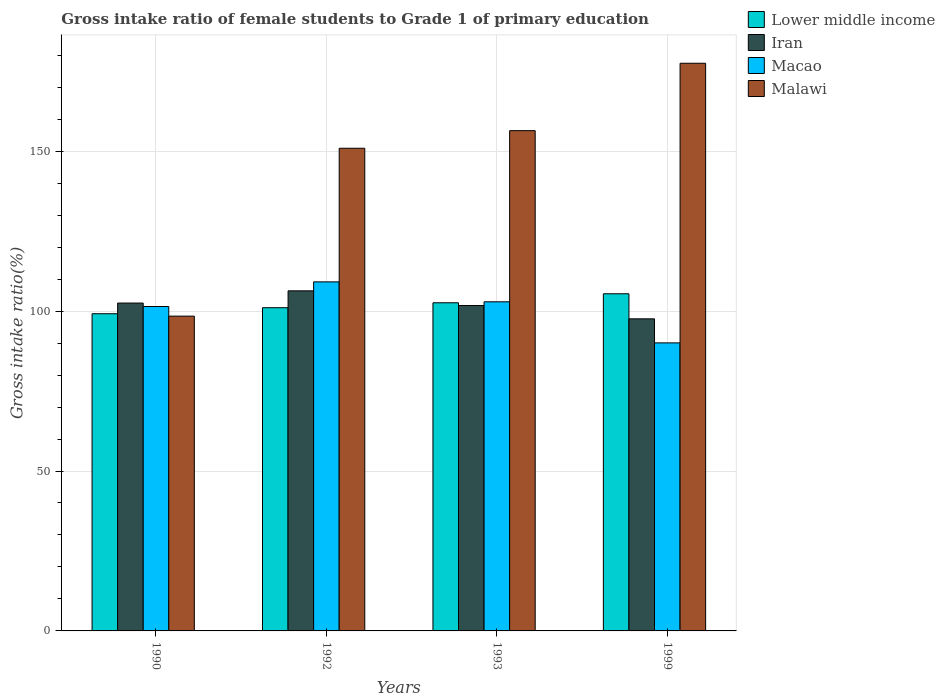How many groups of bars are there?
Provide a succinct answer. 4. What is the label of the 1st group of bars from the left?
Provide a succinct answer. 1990. In how many cases, is the number of bars for a given year not equal to the number of legend labels?
Your response must be concise. 0. What is the gross intake ratio in Iran in 1990?
Make the answer very short. 102.52. Across all years, what is the maximum gross intake ratio in Macao?
Ensure brevity in your answer.  109.15. Across all years, what is the minimum gross intake ratio in Malawi?
Your answer should be very brief. 98.43. In which year was the gross intake ratio in Lower middle income maximum?
Provide a succinct answer. 1999. What is the total gross intake ratio in Iran in the graph?
Make the answer very short. 408.2. What is the difference between the gross intake ratio in Iran in 1992 and that in 1993?
Make the answer very short. 4.59. What is the difference between the gross intake ratio in Macao in 1999 and the gross intake ratio in Malawi in 1990?
Ensure brevity in your answer.  -8.37. What is the average gross intake ratio in Iran per year?
Give a very brief answer. 102.05. In the year 1993, what is the difference between the gross intake ratio in Malawi and gross intake ratio in Macao?
Keep it short and to the point. 53.51. What is the ratio of the gross intake ratio in Macao in 1990 to that in 1992?
Keep it short and to the point. 0.93. What is the difference between the highest and the second highest gross intake ratio in Malawi?
Your answer should be very brief. 21.08. What is the difference between the highest and the lowest gross intake ratio in Macao?
Offer a very short reply. 19.08. In how many years, is the gross intake ratio in Lower middle income greater than the average gross intake ratio in Lower middle income taken over all years?
Your response must be concise. 2. Is it the case that in every year, the sum of the gross intake ratio in Lower middle income and gross intake ratio in Malawi is greater than the sum of gross intake ratio in Macao and gross intake ratio in Iran?
Your answer should be very brief. Yes. What does the 1st bar from the left in 1993 represents?
Your answer should be very brief. Lower middle income. What does the 2nd bar from the right in 1990 represents?
Your answer should be very brief. Macao. Is it the case that in every year, the sum of the gross intake ratio in Lower middle income and gross intake ratio in Malawi is greater than the gross intake ratio in Macao?
Give a very brief answer. Yes. How many years are there in the graph?
Keep it short and to the point. 4. What is the title of the graph?
Your answer should be very brief. Gross intake ratio of female students to Grade 1 of primary education. What is the label or title of the X-axis?
Provide a succinct answer. Years. What is the label or title of the Y-axis?
Keep it short and to the point. Gross intake ratio(%). What is the Gross intake ratio(%) of Lower middle income in 1990?
Give a very brief answer. 99.19. What is the Gross intake ratio(%) of Iran in 1990?
Keep it short and to the point. 102.52. What is the Gross intake ratio(%) of Macao in 1990?
Give a very brief answer. 101.44. What is the Gross intake ratio(%) in Malawi in 1990?
Provide a short and direct response. 98.43. What is the Gross intake ratio(%) in Lower middle income in 1992?
Your answer should be very brief. 101.07. What is the Gross intake ratio(%) of Iran in 1992?
Ensure brevity in your answer.  106.34. What is the Gross intake ratio(%) in Macao in 1992?
Offer a terse response. 109.15. What is the Gross intake ratio(%) in Malawi in 1992?
Give a very brief answer. 150.93. What is the Gross intake ratio(%) in Lower middle income in 1993?
Give a very brief answer. 102.61. What is the Gross intake ratio(%) of Iran in 1993?
Make the answer very short. 101.75. What is the Gross intake ratio(%) in Macao in 1993?
Give a very brief answer. 102.91. What is the Gross intake ratio(%) in Malawi in 1993?
Give a very brief answer. 156.42. What is the Gross intake ratio(%) in Lower middle income in 1999?
Make the answer very short. 105.42. What is the Gross intake ratio(%) of Iran in 1999?
Your answer should be very brief. 97.59. What is the Gross intake ratio(%) in Macao in 1999?
Make the answer very short. 90.07. What is the Gross intake ratio(%) of Malawi in 1999?
Offer a very short reply. 177.5. Across all years, what is the maximum Gross intake ratio(%) of Lower middle income?
Keep it short and to the point. 105.42. Across all years, what is the maximum Gross intake ratio(%) in Iran?
Ensure brevity in your answer.  106.34. Across all years, what is the maximum Gross intake ratio(%) in Macao?
Keep it short and to the point. 109.15. Across all years, what is the maximum Gross intake ratio(%) of Malawi?
Your answer should be compact. 177.5. Across all years, what is the minimum Gross intake ratio(%) in Lower middle income?
Provide a short and direct response. 99.19. Across all years, what is the minimum Gross intake ratio(%) in Iran?
Your answer should be compact. 97.59. Across all years, what is the minimum Gross intake ratio(%) of Macao?
Offer a terse response. 90.07. Across all years, what is the minimum Gross intake ratio(%) in Malawi?
Your answer should be compact. 98.43. What is the total Gross intake ratio(%) in Lower middle income in the graph?
Your answer should be compact. 408.28. What is the total Gross intake ratio(%) in Iran in the graph?
Ensure brevity in your answer.  408.2. What is the total Gross intake ratio(%) in Macao in the graph?
Offer a very short reply. 403.56. What is the total Gross intake ratio(%) of Malawi in the graph?
Give a very brief answer. 583.29. What is the difference between the Gross intake ratio(%) in Lower middle income in 1990 and that in 1992?
Offer a very short reply. -1.88. What is the difference between the Gross intake ratio(%) in Iran in 1990 and that in 1992?
Provide a short and direct response. -3.82. What is the difference between the Gross intake ratio(%) of Macao in 1990 and that in 1992?
Offer a terse response. -7.71. What is the difference between the Gross intake ratio(%) in Malawi in 1990 and that in 1992?
Make the answer very short. -52.5. What is the difference between the Gross intake ratio(%) in Lower middle income in 1990 and that in 1993?
Provide a succinct answer. -3.42. What is the difference between the Gross intake ratio(%) of Iran in 1990 and that in 1993?
Make the answer very short. 0.77. What is the difference between the Gross intake ratio(%) in Macao in 1990 and that in 1993?
Offer a very short reply. -1.47. What is the difference between the Gross intake ratio(%) of Malawi in 1990 and that in 1993?
Your response must be concise. -57.99. What is the difference between the Gross intake ratio(%) in Lower middle income in 1990 and that in 1999?
Keep it short and to the point. -6.24. What is the difference between the Gross intake ratio(%) of Iran in 1990 and that in 1999?
Ensure brevity in your answer.  4.93. What is the difference between the Gross intake ratio(%) of Macao in 1990 and that in 1999?
Offer a very short reply. 11.37. What is the difference between the Gross intake ratio(%) in Malawi in 1990 and that in 1999?
Keep it short and to the point. -79.07. What is the difference between the Gross intake ratio(%) in Lower middle income in 1992 and that in 1993?
Your answer should be very brief. -1.54. What is the difference between the Gross intake ratio(%) in Iran in 1992 and that in 1993?
Offer a terse response. 4.59. What is the difference between the Gross intake ratio(%) of Macao in 1992 and that in 1993?
Offer a very short reply. 6.23. What is the difference between the Gross intake ratio(%) of Malawi in 1992 and that in 1993?
Offer a very short reply. -5.5. What is the difference between the Gross intake ratio(%) in Lower middle income in 1992 and that in 1999?
Ensure brevity in your answer.  -4.36. What is the difference between the Gross intake ratio(%) in Iran in 1992 and that in 1999?
Give a very brief answer. 8.75. What is the difference between the Gross intake ratio(%) of Macao in 1992 and that in 1999?
Your answer should be compact. 19.08. What is the difference between the Gross intake ratio(%) in Malawi in 1992 and that in 1999?
Offer a very short reply. -26.58. What is the difference between the Gross intake ratio(%) in Lower middle income in 1993 and that in 1999?
Keep it short and to the point. -2.81. What is the difference between the Gross intake ratio(%) of Iran in 1993 and that in 1999?
Provide a succinct answer. 4.16. What is the difference between the Gross intake ratio(%) of Macao in 1993 and that in 1999?
Your answer should be compact. 12.85. What is the difference between the Gross intake ratio(%) in Malawi in 1993 and that in 1999?
Your answer should be compact. -21.08. What is the difference between the Gross intake ratio(%) of Lower middle income in 1990 and the Gross intake ratio(%) of Iran in 1992?
Offer a very short reply. -7.16. What is the difference between the Gross intake ratio(%) in Lower middle income in 1990 and the Gross intake ratio(%) in Macao in 1992?
Make the answer very short. -9.96. What is the difference between the Gross intake ratio(%) in Lower middle income in 1990 and the Gross intake ratio(%) in Malawi in 1992?
Provide a short and direct response. -51.74. What is the difference between the Gross intake ratio(%) of Iran in 1990 and the Gross intake ratio(%) of Macao in 1992?
Your answer should be compact. -6.63. What is the difference between the Gross intake ratio(%) of Iran in 1990 and the Gross intake ratio(%) of Malawi in 1992?
Provide a short and direct response. -48.41. What is the difference between the Gross intake ratio(%) of Macao in 1990 and the Gross intake ratio(%) of Malawi in 1992?
Make the answer very short. -49.49. What is the difference between the Gross intake ratio(%) in Lower middle income in 1990 and the Gross intake ratio(%) in Iran in 1993?
Provide a short and direct response. -2.56. What is the difference between the Gross intake ratio(%) in Lower middle income in 1990 and the Gross intake ratio(%) in Macao in 1993?
Your answer should be very brief. -3.72. What is the difference between the Gross intake ratio(%) in Lower middle income in 1990 and the Gross intake ratio(%) in Malawi in 1993?
Ensure brevity in your answer.  -57.24. What is the difference between the Gross intake ratio(%) in Iran in 1990 and the Gross intake ratio(%) in Macao in 1993?
Give a very brief answer. -0.39. What is the difference between the Gross intake ratio(%) of Iran in 1990 and the Gross intake ratio(%) of Malawi in 1993?
Offer a terse response. -53.9. What is the difference between the Gross intake ratio(%) of Macao in 1990 and the Gross intake ratio(%) of Malawi in 1993?
Provide a short and direct response. -54.98. What is the difference between the Gross intake ratio(%) in Lower middle income in 1990 and the Gross intake ratio(%) in Iran in 1999?
Your answer should be very brief. 1.6. What is the difference between the Gross intake ratio(%) in Lower middle income in 1990 and the Gross intake ratio(%) in Macao in 1999?
Offer a very short reply. 9.12. What is the difference between the Gross intake ratio(%) in Lower middle income in 1990 and the Gross intake ratio(%) in Malawi in 1999?
Your answer should be very brief. -78.32. What is the difference between the Gross intake ratio(%) in Iran in 1990 and the Gross intake ratio(%) in Macao in 1999?
Offer a very short reply. 12.45. What is the difference between the Gross intake ratio(%) of Iran in 1990 and the Gross intake ratio(%) of Malawi in 1999?
Make the answer very short. -74.98. What is the difference between the Gross intake ratio(%) of Macao in 1990 and the Gross intake ratio(%) of Malawi in 1999?
Make the answer very short. -76.06. What is the difference between the Gross intake ratio(%) in Lower middle income in 1992 and the Gross intake ratio(%) in Iran in 1993?
Provide a short and direct response. -0.68. What is the difference between the Gross intake ratio(%) of Lower middle income in 1992 and the Gross intake ratio(%) of Macao in 1993?
Your answer should be compact. -1.85. What is the difference between the Gross intake ratio(%) in Lower middle income in 1992 and the Gross intake ratio(%) in Malawi in 1993?
Provide a succinct answer. -55.36. What is the difference between the Gross intake ratio(%) of Iran in 1992 and the Gross intake ratio(%) of Macao in 1993?
Offer a very short reply. 3.43. What is the difference between the Gross intake ratio(%) in Iran in 1992 and the Gross intake ratio(%) in Malawi in 1993?
Offer a terse response. -50.08. What is the difference between the Gross intake ratio(%) in Macao in 1992 and the Gross intake ratio(%) in Malawi in 1993?
Provide a short and direct response. -47.28. What is the difference between the Gross intake ratio(%) of Lower middle income in 1992 and the Gross intake ratio(%) of Iran in 1999?
Provide a short and direct response. 3.48. What is the difference between the Gross intake ratio(%) of Lower middle income in 1992 and the Gross intake ratio(%) of Macao in 1999?
Offer a very short reply. 11. What is the difference between the Gross intake ratio(%) in Lower middle income in 1992 and the Gross intake ratio(%) in Malawi in 1999?
Keep it short and to the point. -76.44. What is the difference between the Gross intake ratio(%) in Iran in 1992 and the Gross intake ratio(%) in Macao in 1999?
Offer a very short reply. 16.28. What is the difference between the Gross intake ratio(%) of Iran in 1992 and the Gross intake ratio(%) of Malawi in 1999?
Make the answer very short. -71.16. What is the difference between the Gross intake ratio(%) of Macao in 1992 and the Gross intake ratio(%) of Malawi in 1999?
Make the answer very short. -68.36. What is the difference between the Gross intake ratio(%) of Lower middle income in 1993 and the Gross intake ratio(%) of Iran in 1999?
Keep it short and to the point. 5.02. What is the difference between the Gross intake ratio(%) in Lower middle income in 1993 and the Gross intake ratio(%) in Macao in 1999?
Keep it short and to the point. 12.54. What is the difference between the Gross intake ratio(%) of Lower middle income in 1993 and the Gross intake ratio(%) of Malawi in 1999?
Offer a very short reply. -74.9. What is the difference between the Gross intake ratio(%) of Iran in 1993 and the Gross intake ratio(%) of Macao in 1999?
Your response must be concise. 11.68. What is the difference between the Gross intake ratio(%) of Iran in 1993 and the Gross intake ratio(%) of Malawi in 1999?
Give a very brief answer. -75.76. What is the difference between the Gross intake ratio(%) in Macao in 1993 and the Gross intake ratio(%) in Malawi in 1999?
Provide a short and direct response. -74.59. What is the average Gross intake ratio(%) of Lower middle income per year?
Provide a succinct answer. 102.07. What is the average Gross intake ratio(%) of Iran per year?
Provide a short and direct response. 102.05. What is the average Gross intake ratio(%) in Macao per year?
Your answer should be very brief. 100.89. What is the average Gross intake ratio(%) of Malawi per year?
Your answer should be compact. 145.82. In the year 1990, what is the difference between the Gross intake ratio(%) in Lower middle income and Gross intake ratio(%) in Iran?
Keep it short and to the point. -3.33. In the year 1990, what is the difference between the Gross intake ratio(%) in Lower middle income and Gross intake ratio(%) in Macao?
Make the answer very short. -2.25. In the year 1990, what is the difference between the Gross intake ratio(%) in Lower middle income and Gross intake ratio(%) in Malawi?
Provide a short and direct response. 0.75. In the year 1990, what is the difference between the Gross intake ratio(%) of Iran and Gross intake ratio(%) of Macao?
Provide a short and direct response. 1.08. In the year 1990, what is the difference between the Gross intake ratio(%) of Iran and Gross intake ratio(%) of Malawi?
Give a very brief answer. 4.09. In the year 1990, what is the difference between the Gross intake ratio(%) of Macao and Gross intake ratio(%) of Malawi?
Offer a very short reply. 3.01. In the year 1992, what is the difference between the Gross intake ratio(%) in Lower middle income and Gross intake ratio(%) in Iran?
Your response must be concise. -5.28. In the year 1992, what is the difference between the Gross intake ratio(%) in Lower middle income and Gross intake ratio(%) in Macao?
Offer a very short reply. -8.08. In the year 1992, what is the difference between the Gross intake ratio(%) of Lower middle income and Gross intake ratio(%) of Malawi?
Your answer should be compact. -49.86. In the year 1992, what is the difference between the Gross intake ratio(%) of Iran and Gross intake ratio(%) of Macao?
Offer a terse response. -2.8. In the year 1992, what is the difference between the Gross intake ratio(%) of Iran and Gross intake ratio(%) of Malawi?
Offer a terse response. -44.58. In the year 1992, what is the difference between the Gross intake ratio(%) of Macao and Gross intake ratio(%) of Malawi?
Offer a terse response. -41.78. In the year 1993, what is the difference between the Gross intake ratio(%) of Lower middle income and Gross intake ratio(%) of Iran?
Make the answer very short. 0.86. In the year 1993, what is the difference between the Gross intake ratio(%) of Lower middle income and Gross intake ratio(%) of Macao?
Your answer should be compact. -0.3. In the year 1993, what is the difference between the Gross intake ratio(%) of Lower middle income and Gross intake ratio(%) of Malawi?
Your response must be concise. -53.82. In the year 1993, what is the difference between the Gross intake ratio(%) of Iran and Gross intake ratio(%) of Macao?
Offer a terse response. -1.16. In the year 1993, what is the difference between the Gross intake ratio(%) in Iran and Gross intake ratio(%) in Malawi?
Ensure brevity in your answer.  -54.68. In the year 1993, what is the difference between the Gross intake ratio(%) of Macao and Gross intake ratio(%) of Malawi?
Offer a terse response. -53.51. In the year 1999, what is the difference between the Gross intake ratio(%) in Lower middle income and Gross intake ratio(%) in Iran?
Make the answer very short. 7.83. In the year 1999, what is the difference between the Gross intake ratio(%) of Lower middle income and Gross intake ratio(%) of Macao?
Provide a succinct answer. 15.36. In the year 1999, what is the difference between the Gross intake ratio(%) in Lower middle income and Gross intake ratio(%) in Malawi?
Your answer should be compact. -72.08. In the year 1999, what is the difference between the Gross intake ratio(%) in Iran and Gross intake ratio(%) in Macao?
Your answer should be compact. 7.52. In the year 1999, what is the difference between the Gross intake ratio(%) in Iran and Gross intake ratio(%) in Malawi?
Provide a succinct answer. -79.92. In the year 1999, what is the difference between the Gross intake ratio(%) in Macao and Gross intake ratio(%) in Malawi?
Keep it short and to the point. -87.44. What is the ratio of the Gross intake ratio(%) in Lower middle income in 1990 to that in 1992?
Offer a very short reply. 0.98. What is the ratio of the Gross intake ratio(%) in Iran in 1990 to that in 1992?
Provide a short and direct response. 0.96. What is the ratio of the Gross intake ratio(%) in Macao in 1990 to that in 1992?
Your response must be concise. 0.93. What is the ratio of the Gross intake ratio(%) of Malawi in 1990 to that in 1992?
Offer a very short reply. 0.65. What is the ratio of the Gross intake ratio(%) of Lower middle income in 1990 to that in 1993?
Offer a very short reply. 0.97. What is the ratio of the Gross intake ratio(%) of Iran in 1990 to that in 1993?
Your response must be concise. 1.01. What is the ratio of the Gross intake ratio(%) of Macao in 1990 to that in 1993?
Your answer should be compact. 0.99. What is the ratio of the Gross intake ratio(%) in Malawi in 1990 to that in 1993?
Provide a short and direct response. 0.63. What is the ratio of the Gross intake ratio(%) in Lower middle income in 1990 to that in 1999?
Your answer should be very brief. 0.94. What is the ratio of the Gross intake ratio(%) in Iran in 1990 to that in 1999?
Keep it short and to the point. 1.05. What is the ratio of the Gross intake ratio(%) of Macao in 1990 to that in 1999?
Offer a terse response. 1.13. What is the ratio of the Gross intake ratio(%) in Malawi in 1990 to that in 1999?
Give a very brief answer. 0.55. What is the ratio of the Gross intake ratio(%) of Iran in 1992 to that in 1993?
Offer a very short reply. 1.05. What is the ratio of the Gross intake ratio(%) of Macao in 1992 to that in 1993?
Your response must be concise. 1.06. What is the ratio of the Gross intake ratio(%) of Malawi in 1992 to that in 1993?
Your answer should be compact. 0.96. What is the ratio of the Gross intake ratio(%) in Lower middle income in 1992 to that in 1999?
Offer a very short reply. 0.96. What is the ratio of the Gross intake ratio(%) in Iran in 1992 to that in 1999?
Provide a succinct answer. 1.09. What is the ratio of the Gross intake ratio(%) of Macao in 1992 to that in 1999?
Keep it short and to the point. 1.21. What is the ratio of the Gross intake ratio(%) of Malawi in 1992 to that in 1999?
Provide a succinct answer. 0.85. What is the ratio of the Gross intake ratio(%) of Lower middle income in 1993 to that in 1999?
Provide a short and direct response. 0.97. What is the ratio of the Gross intake ratio(%) in Iran in 1993 to that in 1999?
Offer a terse response. 1.04. What is the ratio of the Gross intake ratio(%) in Macao in 1993 to that in 1999?
Give a very brief answer. 1.14. What is the ratio of the Gross intake ratio(%) of Malawi in 1993 to that in 1999?
Your answer should be very brief. 0.88. What is the difference between the highest and the second highest Gross intake ratio(%) of Lower middle income?
Provide a succinct answer. 2.81. What is the difference between the highest and the second highest Gross intake ratio(%) of Iran?
Your answer should be very brief. 3.82. What is the difference between the highest and the second highest Gross intake ratio(%) in Macao?
Your answer should be compact. 6.23. What is the difference between the highest and the second highest Gross intake ratio(%) in Malawi?
Offer a terse response. 21.08. What is the difference between the highest and the lowest Gross intake ratio(%) in Lower middle income?
Give a very brief answer. 6.24. What is the difference between the highest and the lowest Gross intake ratio(%) in Iran?
Provide a short and direct response. 8.75. What is the difference between the highest and the lowest Gross intake ratio(%) in Macao?
Give a very brief answer. 19.08. What is the difference between the highest and the lowest Gross intake ratio(%) in Malawi?
Offer a terse response. 79.07. 